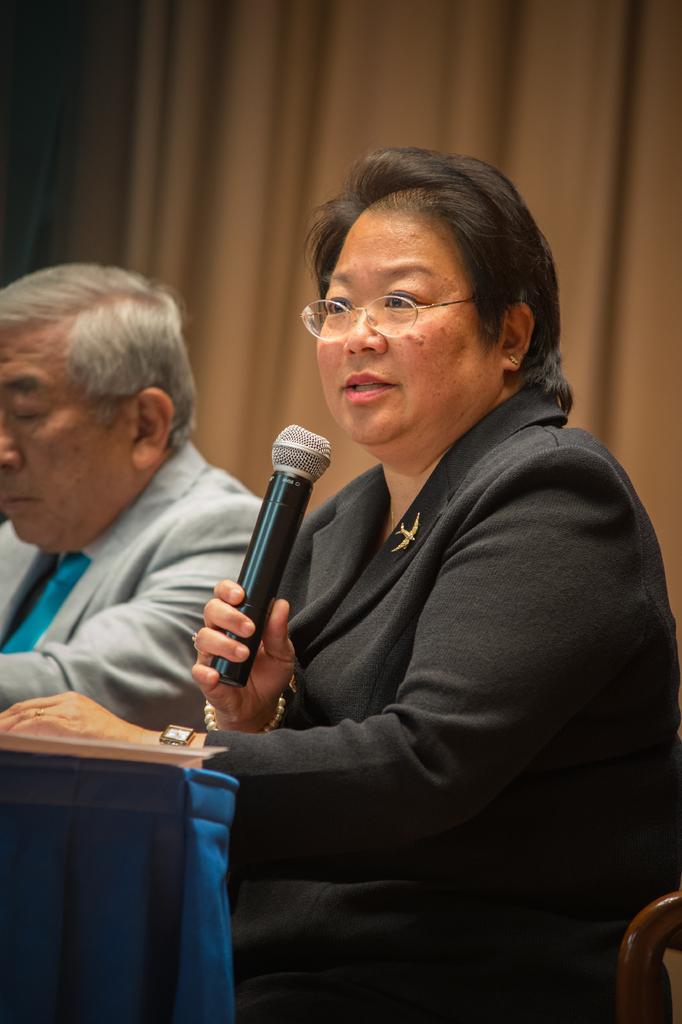Could you give a brief overview of what you see in this image? In this image we can see a person sitting on the chairs at the table. On the table there is a person. In the background we can see curtain. 